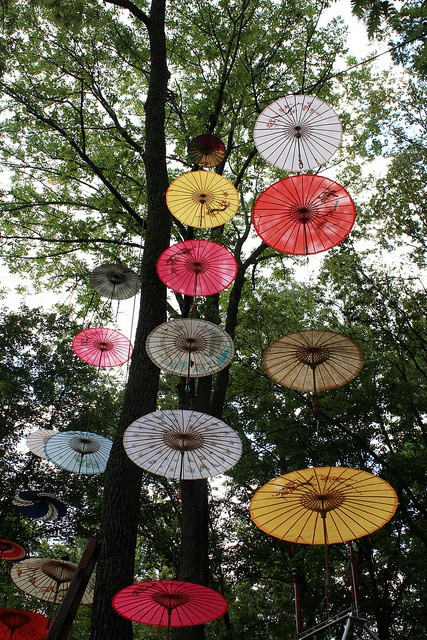Describe the objects in this image and their specific colors. I can see umbrella in black, olive, and tan tones, umbrella in black, salmon, brown, maroon, and lightpink tones, umbrella in black, darkgray, and gray tones, umbrella in black, lightgray, darkgray, and gray tones, and umbrella in black, gray, and tan tones in this image. 